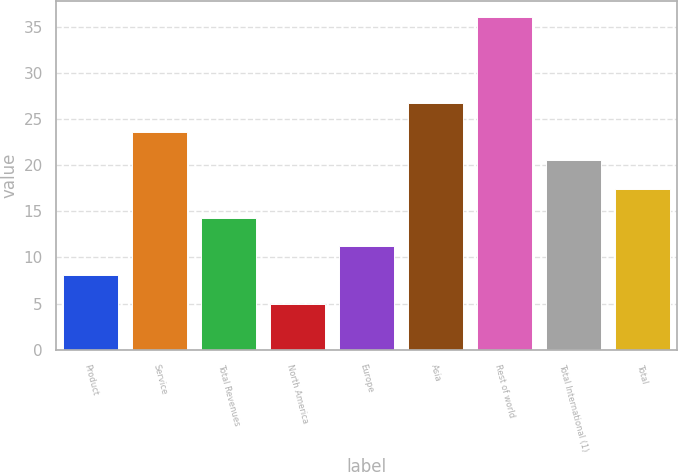Convert chart. <chart><loc_0><loc_0><loc_500><loc_500><bar_chart><fcel>Product<fcel>Service<fcel>Total Revenues<fcel>North America<fcel>Europe<fcel>Asia<fcel>Rest of world<fcel>Total International (1)<fcel>Total<nl><fcel>8.1<fcel>23.6<fcel>14.3<fcel>5<fcel>11.2<fcel>26.7<fcel>36<fcel>20.5<fcel>17.4<nl></chart> 